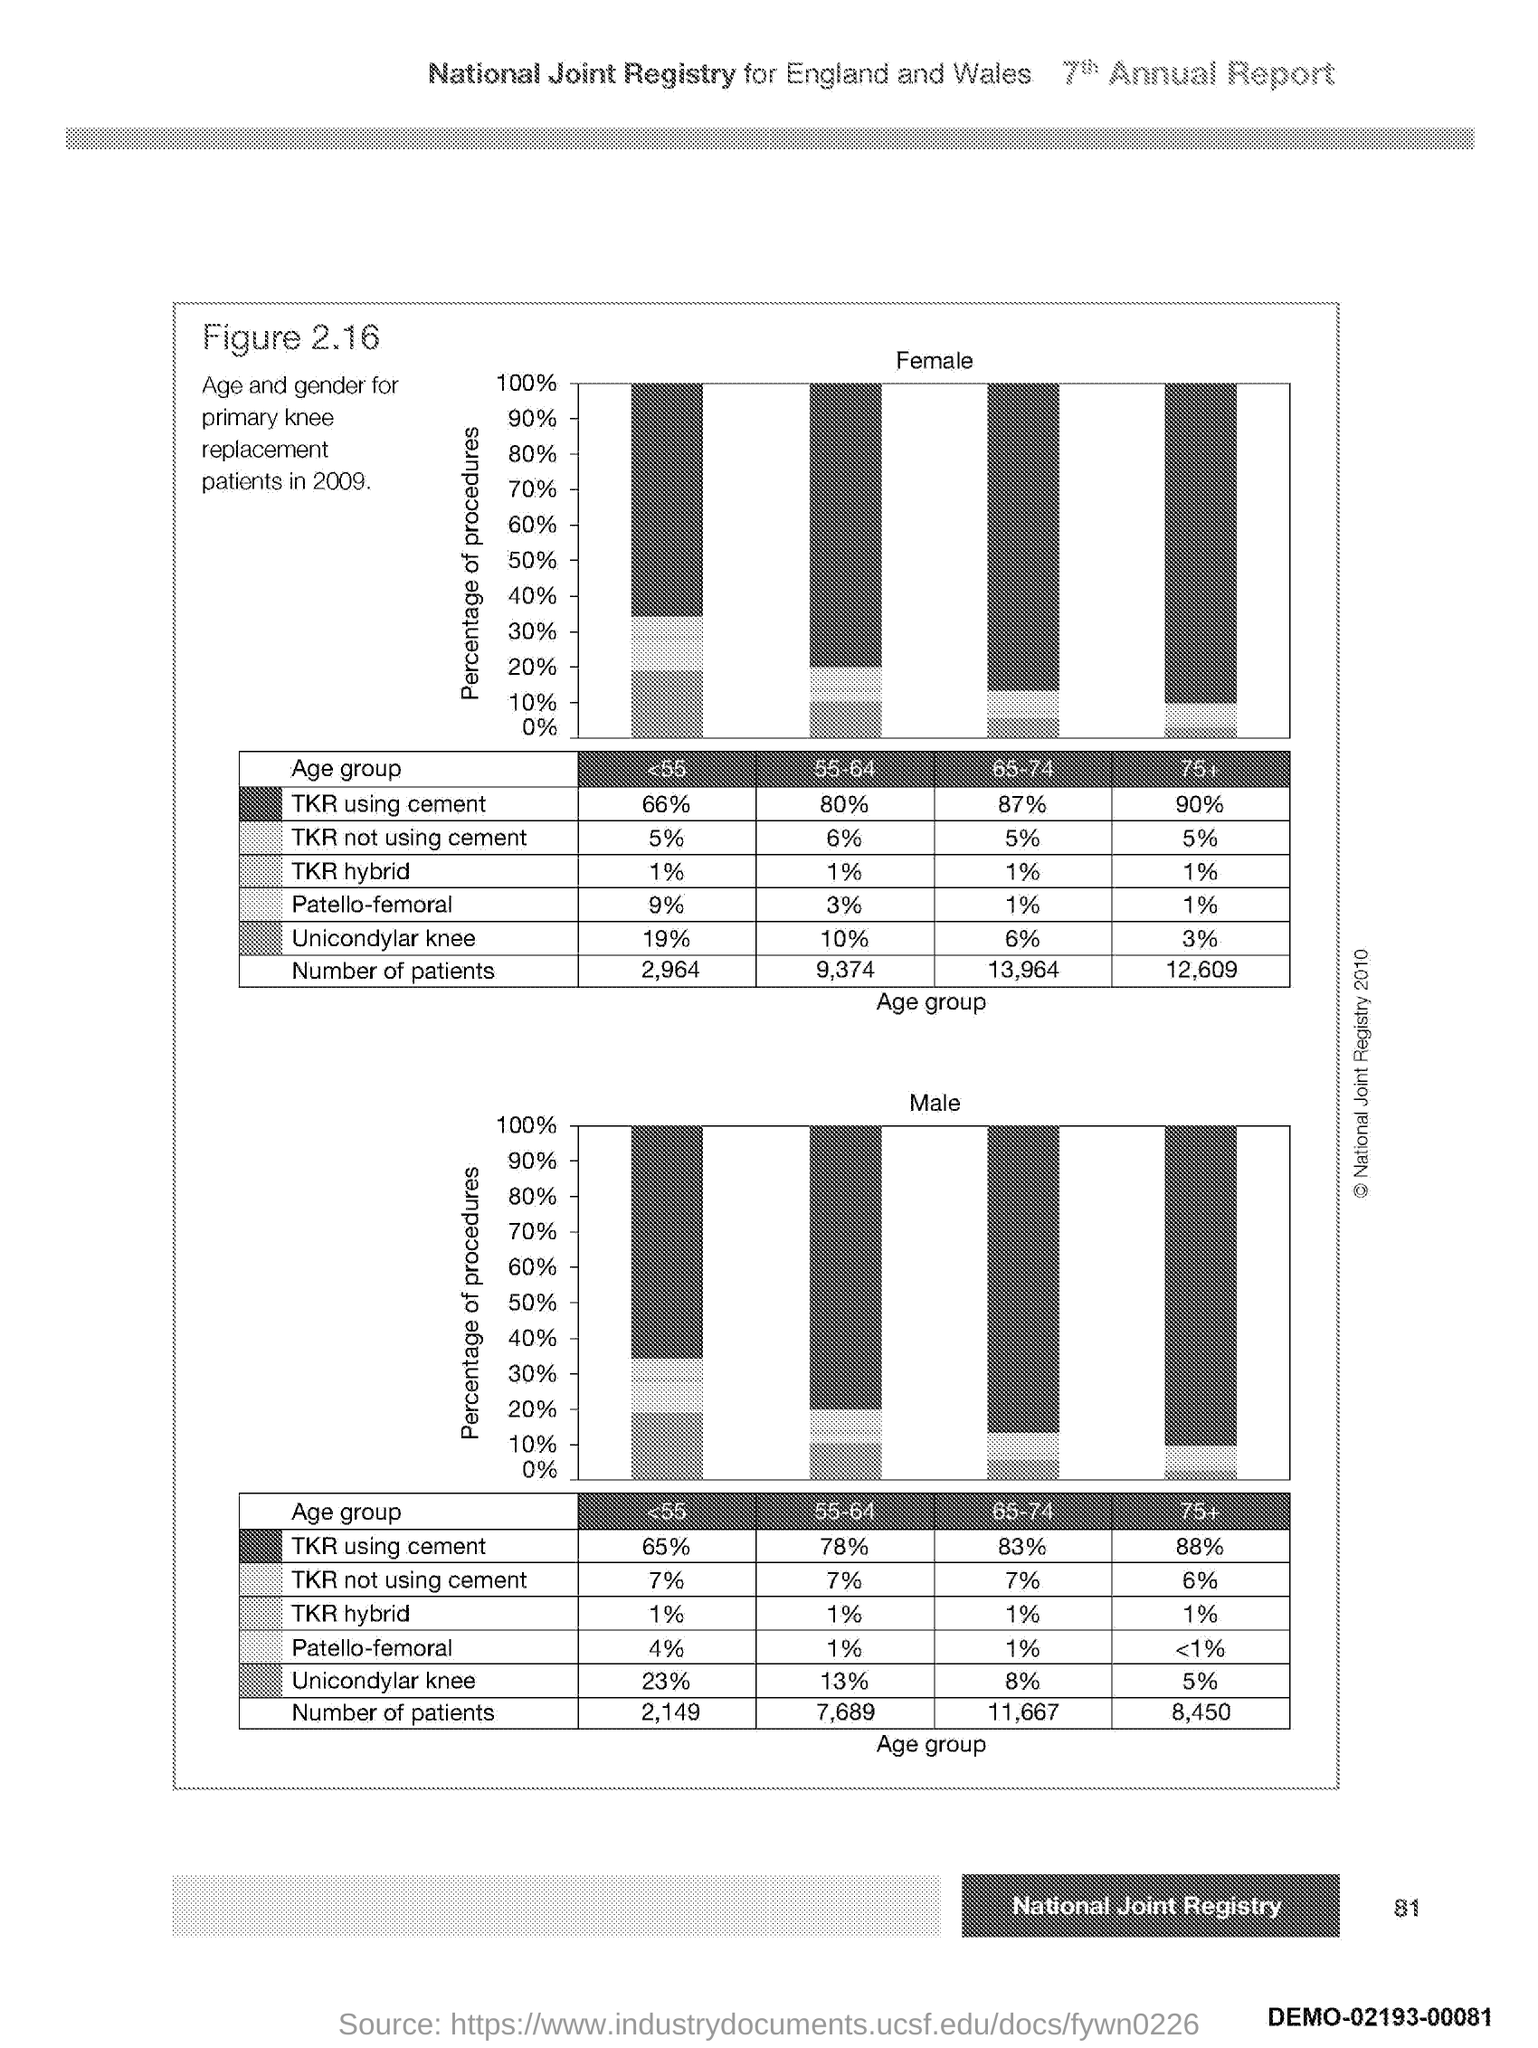What is plotted in the y-axis of first graph?
Give a very brief answer. Percentage of procedures. What is plotted in the y-axis of second graph?
Offer a very short reply. Percentage of procedures. 